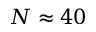<formula> <loc_0><loc_0><loc_500><loc_500>N \approx 4 0</formula> 